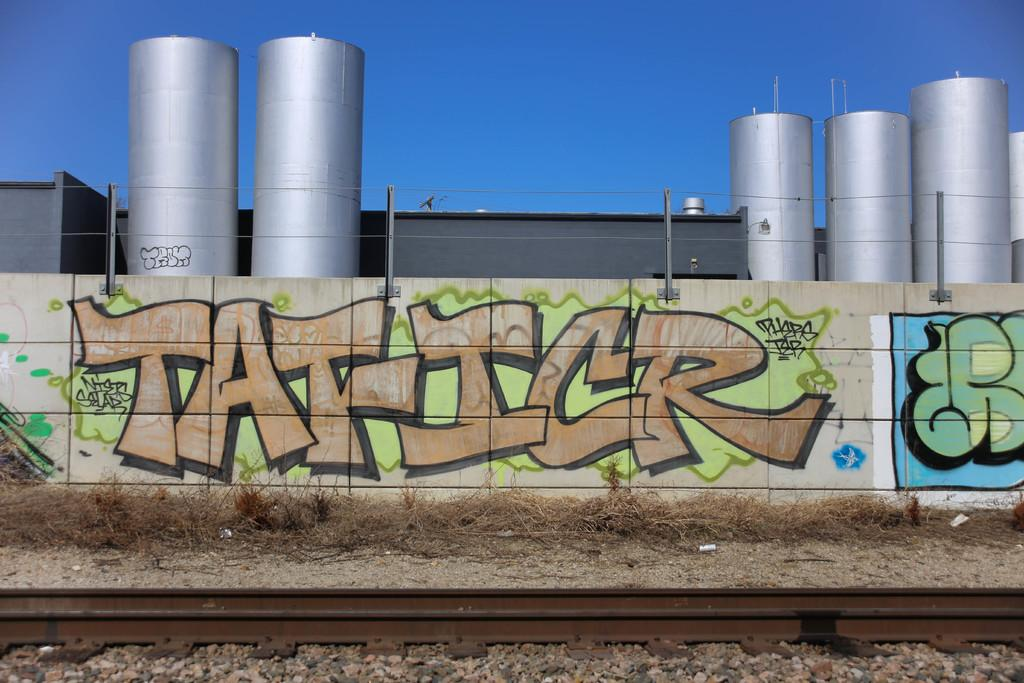<image>
Create a compact narrative representing the image presented. On the wall portion of the fence surrounding an industrial plant is graffiti with the word Taficr. 